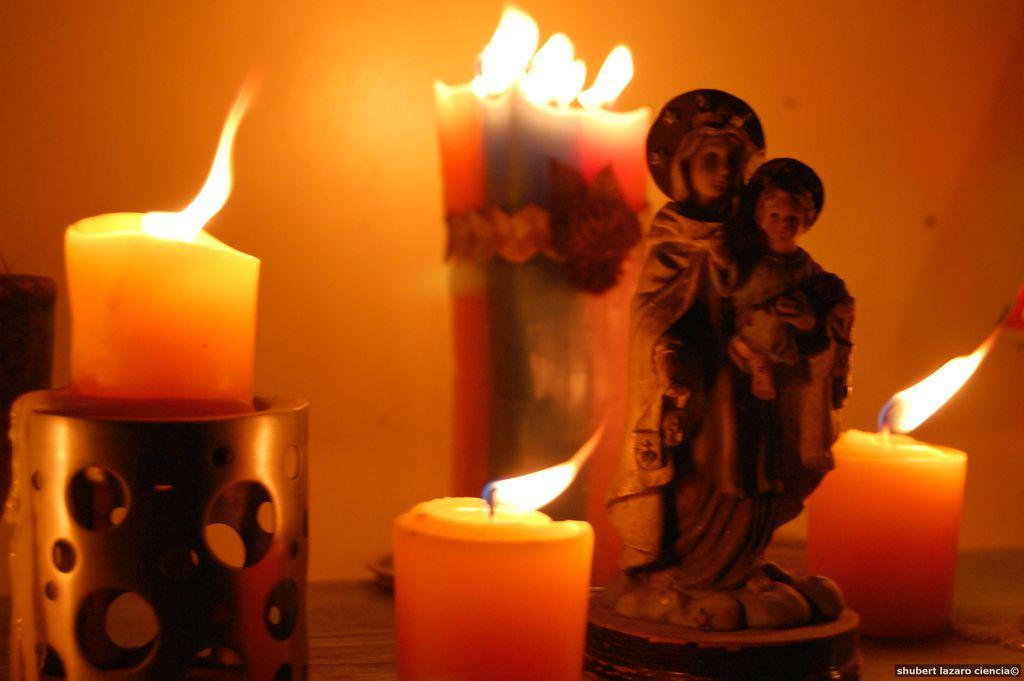What is the main subject in the foreground of the image? There is a statue in the foreground of the image. What objects can be seen in the image besides the statue? There are candles visible in the image. What can be seen in the background of the image? There is a wall in the background of the image. What is the surface on which the statue and candles are placed? There is a floor visible at the bottom of the image. Can you tell me how many times the statue crushes the candles in the image? There is no indication in the image that the statue is crushing the candles, so it cannot be determined from the image. 